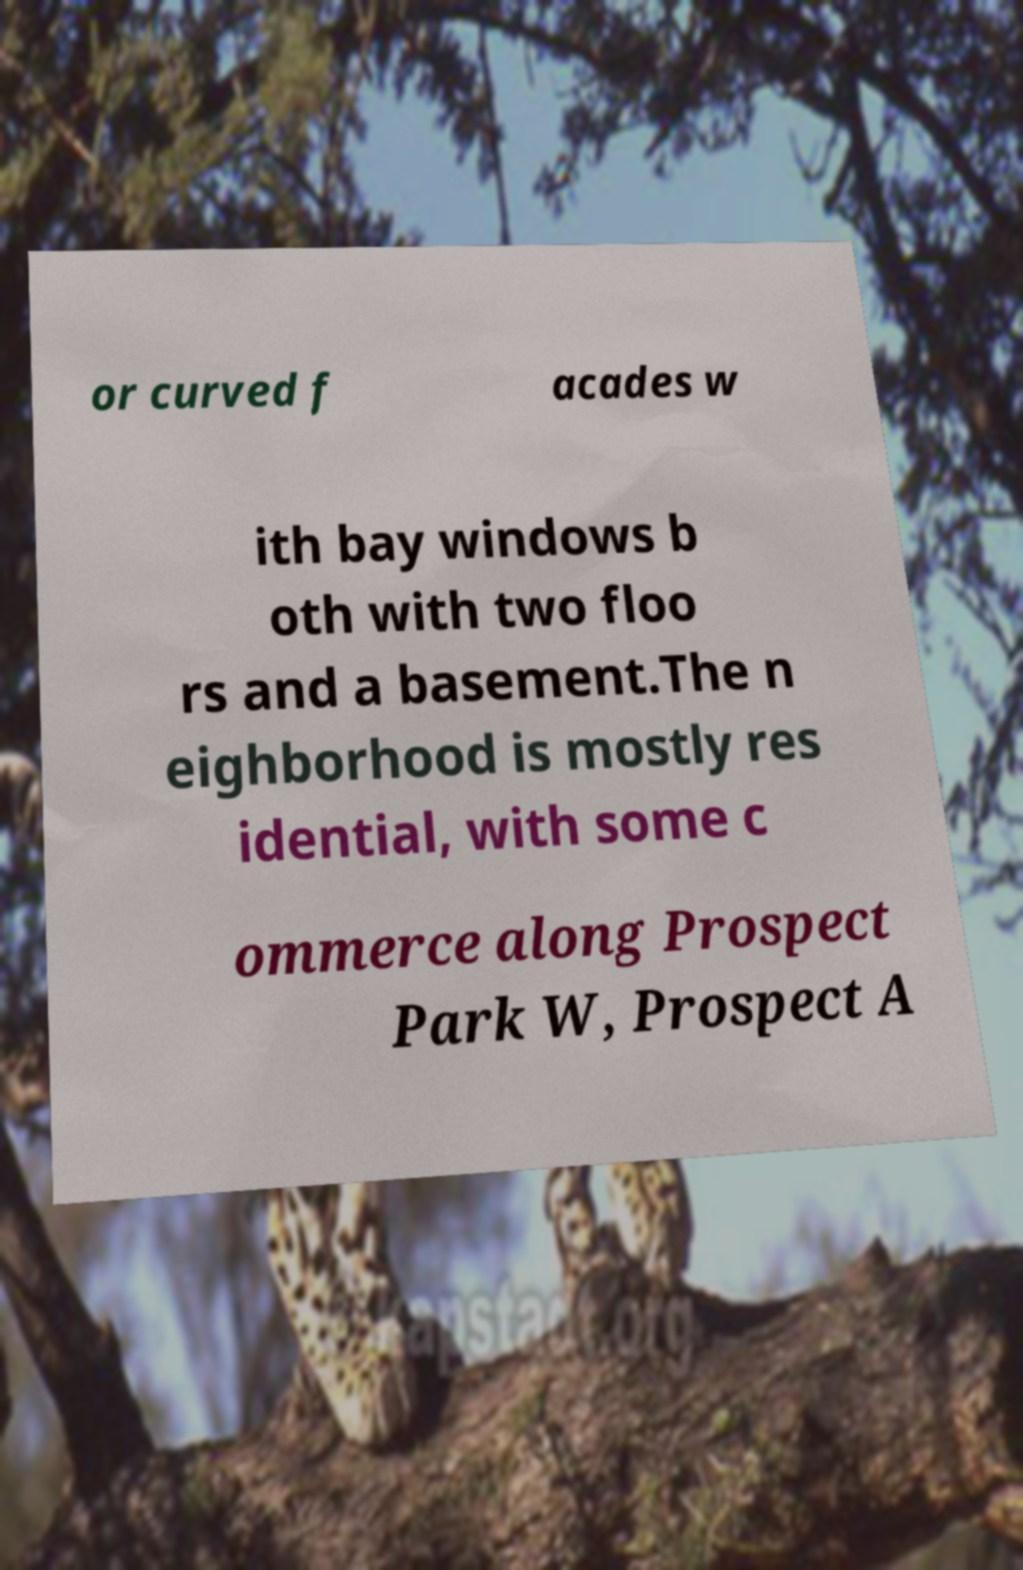Could you assist in decoding the text presented in this image and type it out clearly? or curved f acades w ith bay windows b oth with two floo rs and a basement.The n eighborhood is mostly res idential, with some c ommerce along Prospect Park W, Prospect A 